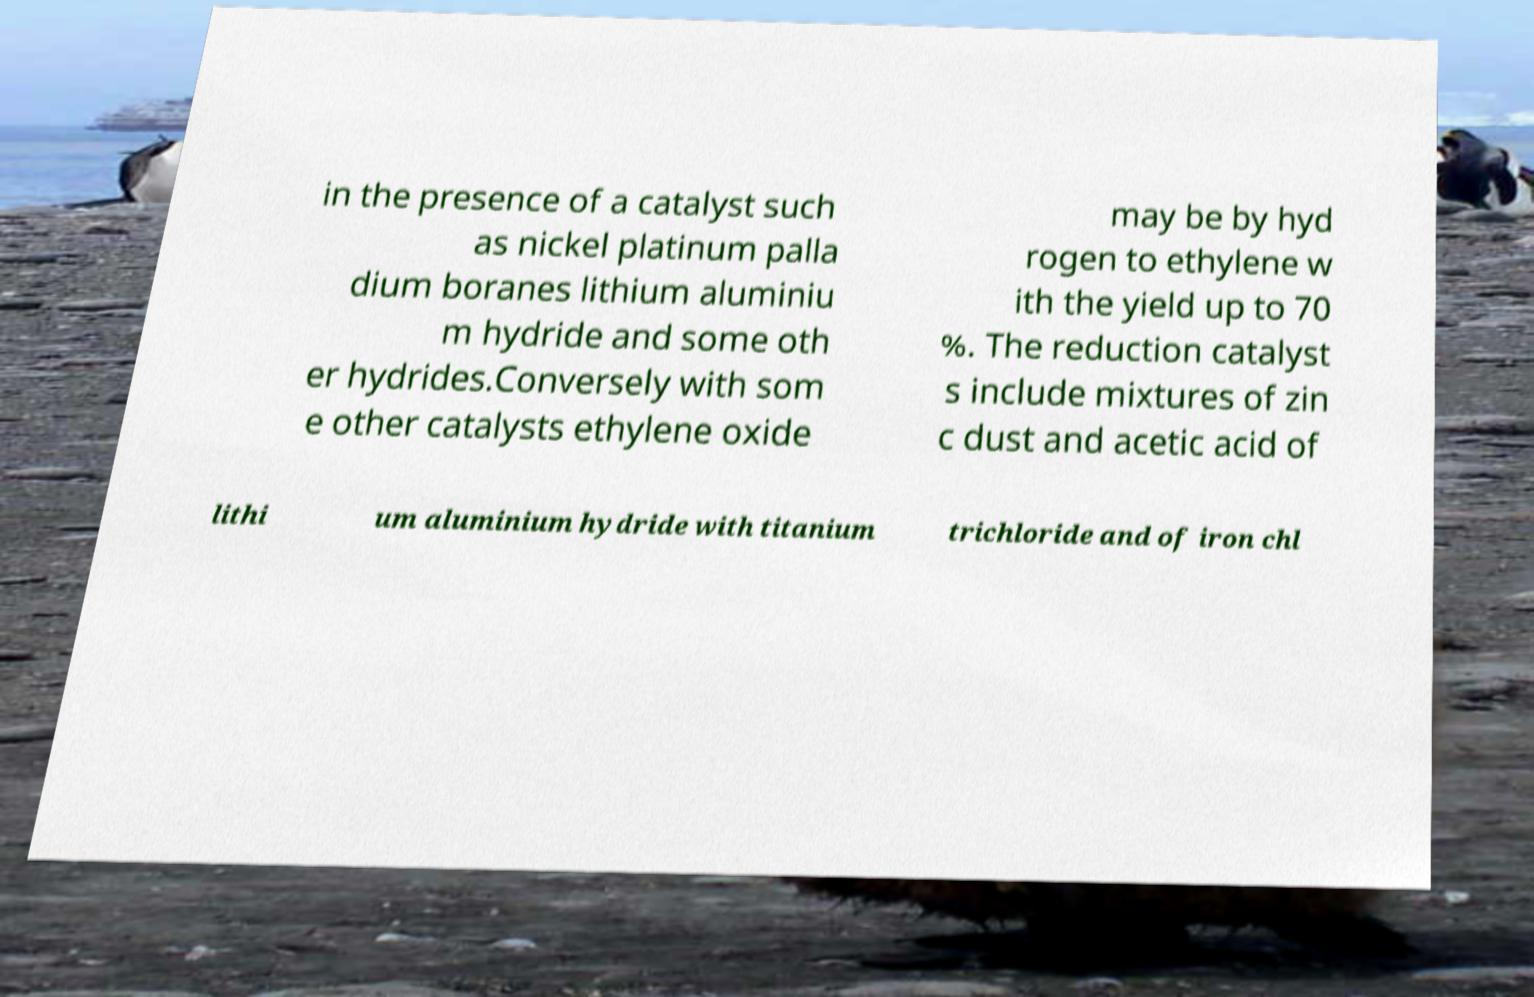Could you assist in decoding the text presented in this image and type it out clearly? in the presence of a catalyst such as nickel platinum palla dium boranes lithium aluminiu m hydride and some oth er hydrides.Conversely with som e other catalysts ethylene oxide may be by hyd rogen to ethylene w ith the yield up to 70 %. The reduction catalyst s include mixtures of zin c dust and acetic acid of lithi um aluminium hydride with titanium trichloride and of iron chl 